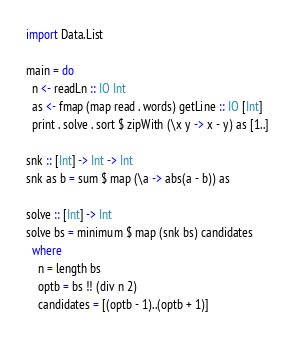<code> <loc_0><loc_0><loc_500><loc_500><_Haskell_>import Data.List

main = do
  n <- readLn :: IO Int
  as <- fmap (map read . words) getLine :: IO [Int]
  print . solve . sort $ zipWith (\x y -> x - y) as [1..]

snk :: [Int] -> Int -> Int
snk as b = sum $ map (\a -> abs(a - b)) as

solve :: [Int] -> Int
solve bs = minimum $ map (snk bs) candidates
  where
    n = length bs
    optb = bs !! (div n 2)
    candidates = [(optb - 1)..(optb + 1)]

</code> 